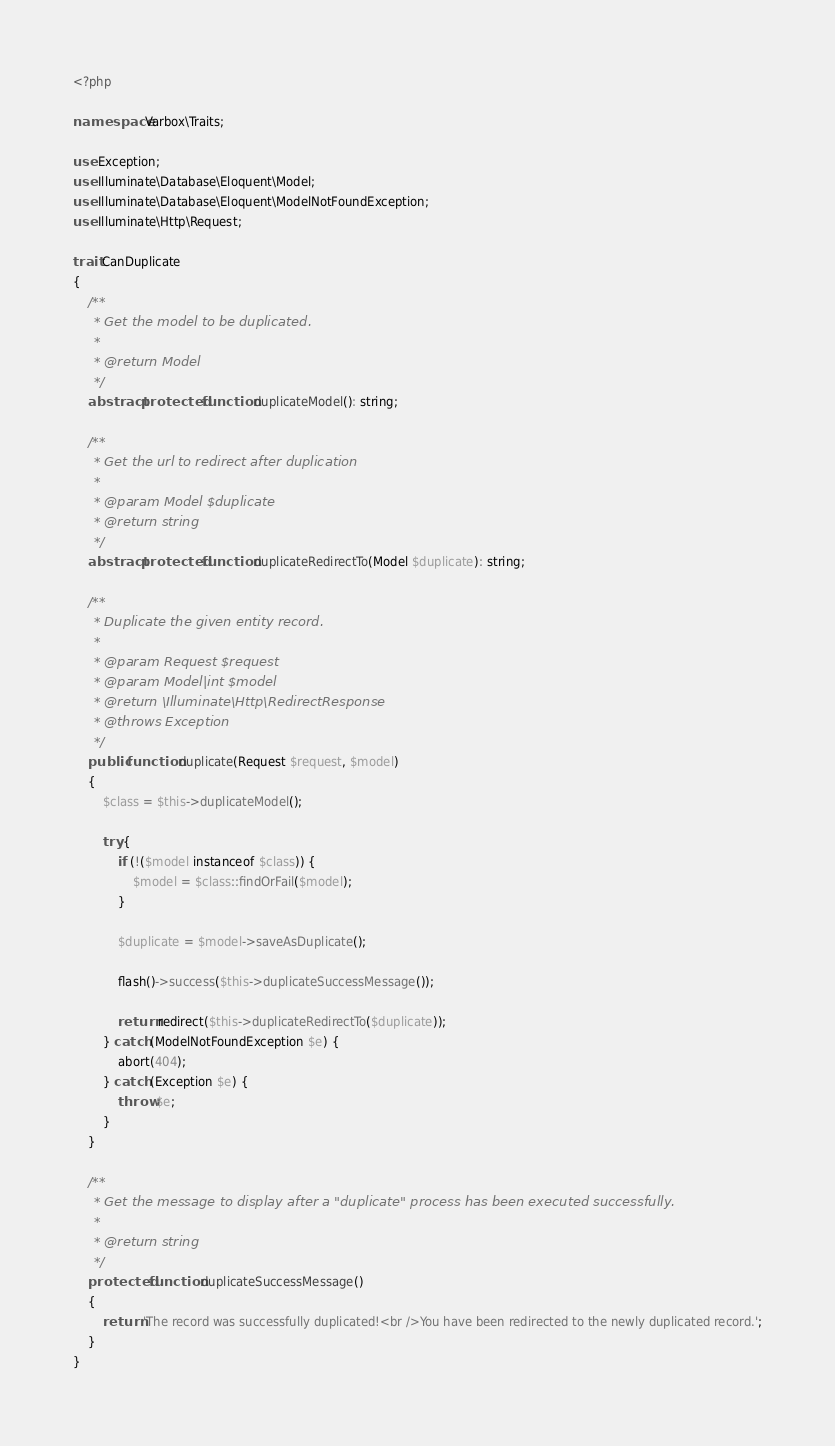Convert code to text. <code><loc_0><loc_0><loc_500><loc_500><_PHP_><?php

namespace Varbox\Traits;

use Exception;
use Illuminate\Database\Eloquent\Model;
use Illuminate\Database\Eloquent\ModelNotFoundException;
use Illuminate\Http\Request;

trait CanDuplicate
{
    /**
     * Get the model to be duplicated.
     *
     * @return Model
     */
    abstract protected function duplicateModel(): string;

    /**
     * Get the url to redirect after duplication
     *
     * @param Model $duplicate
     * @return string
     */
    abstract protected function duplicateRedirectTo(Model $duplicate): string;

    /**
     * Duplicate the given entity record.
     *
     * @param Request $request
     * @param Model|int $model
     * @return \Illuminate\Http\RedirectResponse
     * @throws Exception
     */
    public function duplicate(Request $request, $model)
    {
        $class = $this->duplicateModel();

        try {
            if (!($model instanceof $class)) {
                $model = $class::findOrFail($model);
            }

            $duplicate = $model->saveAsDuplicate();

            flash()->success($this->duplicateSuccessMessage());

            return redirect($this->duplicateRedirectTo($duplicate));
        } catch (ModelNotFoundException $e) {
            abort(404);
        } catch (Exception $e) {
            throw $e;
        }
    }

    /**
     * Get the message to display after a "duplicate" process has been executed successfully.
     *
     * @return string
     */
    protected function duplicateSuccessMessage()
    {
        return 'The record was successfully duplicated!<br />You have been redirected to the newly duplicated record.';
    }
}
</code> 